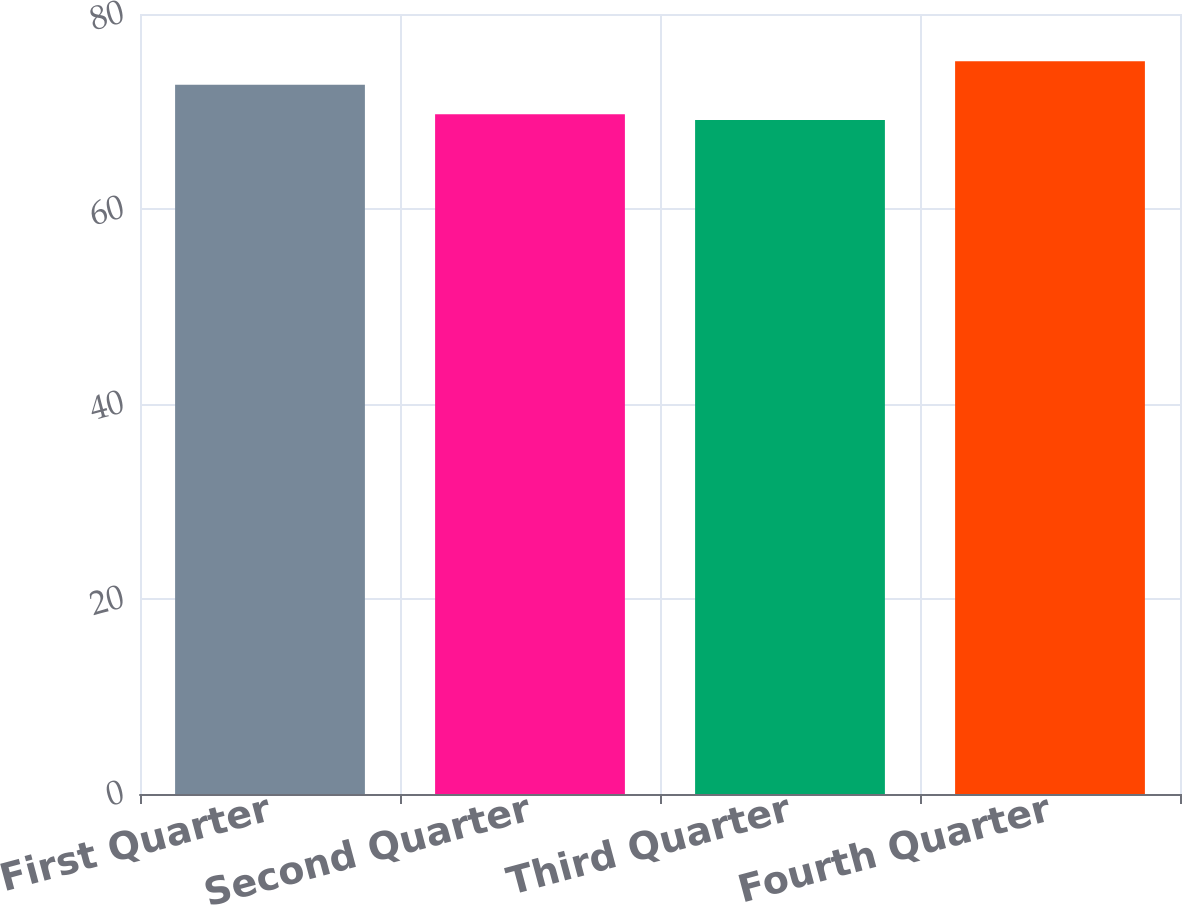Convert chart. <chart><loc_0><loc_0><loc_500><loc_500><bar_chart><fcel>First Quarter<fcel>Second Quarter<fcel>Third Quarter<fcel>Fourth Quarter<nl><fcel>72.74<fcel>69.73<fcel>69.13<fcel>75.15<nl></chart> 